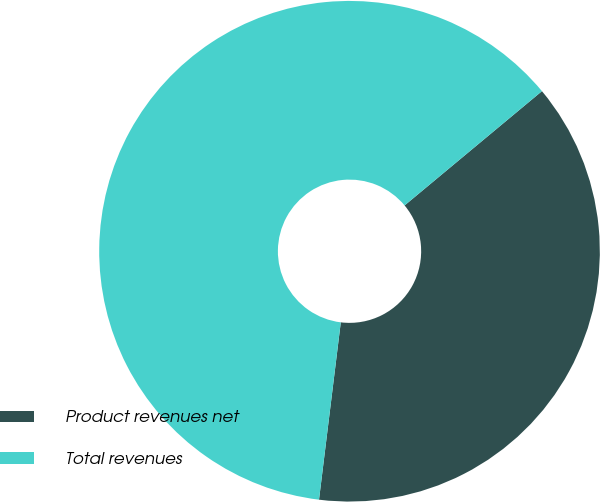Convert chart. <chart><loc_0><loc_0><loc_500><loc_500><pie_chart><fcel>Product revenues net<fcel>Total revenues<nl><fcel>37.99%<fcel>62.01%<nl></chart> 